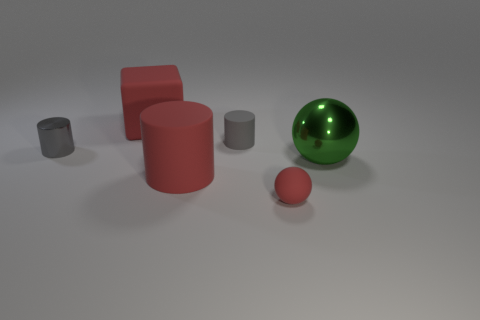Add 3 red balls. How many objects exist? 9 Subtract all balls. How many objects are left? 4 Add 3 red spheres. How many red spheres are left? 4 Add 5 big metallic spheres. How many big metallic spheres exist? 6 Subtract 1 red blocks. How many objects are left? 5 Subtract all gray spheres. Subtract all rubber cylinders. How many objects are left? 4 